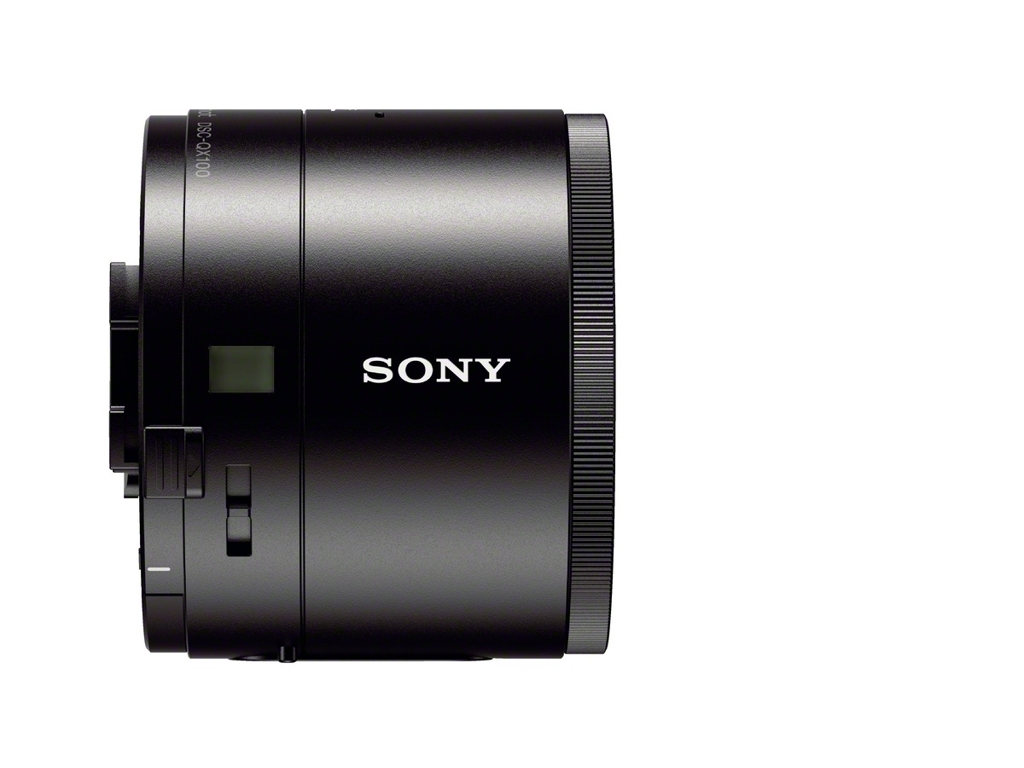Are there any quality issues with this image? The image is of high quality showing a detailed product shot of a cylindrical device with 'SONY' branding, and there are no apparent visual quality issues such as blurriness or pixelation. 